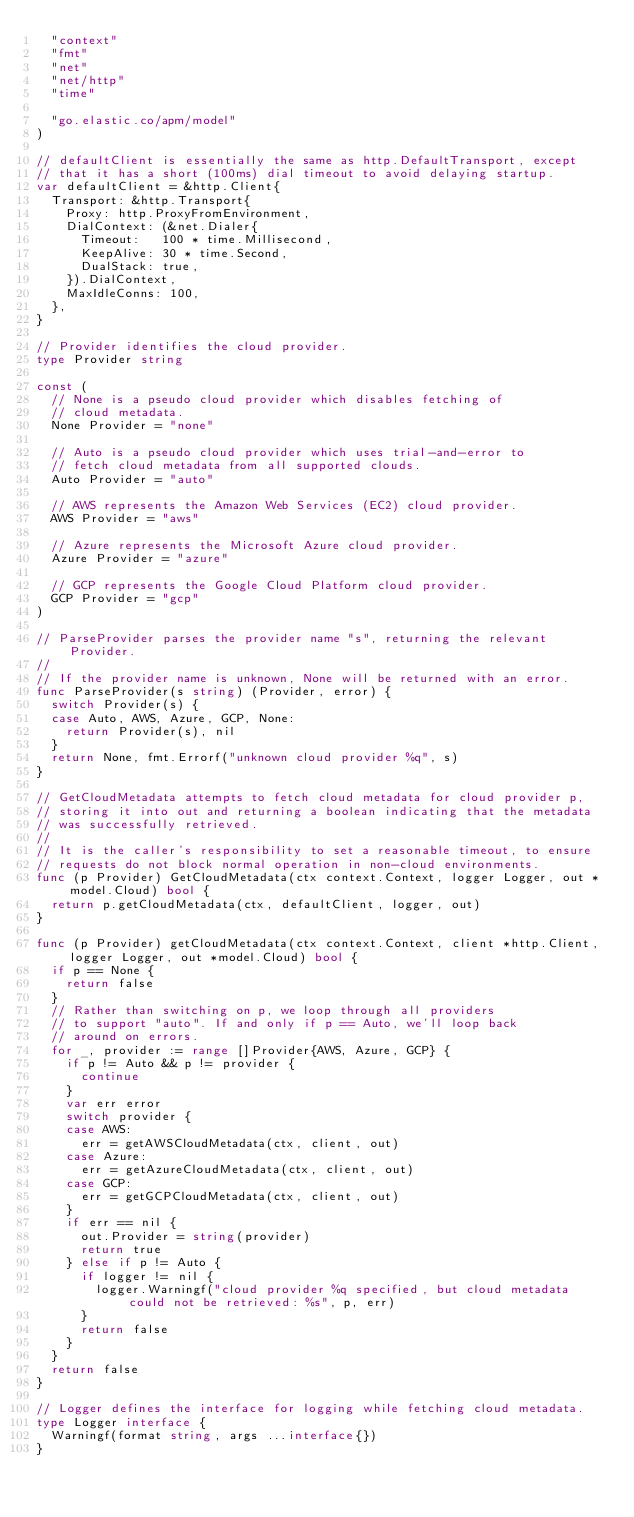<code> <loc_0><loc_0><loc_500><loc_500><_Go_>	"context"
	"fmt"
	"net"
	"net/http"
	"time"

	"go.elastic.co/apm/model"
)

// defaultClient is essentially the same as http.DefaultTransport, except
// that it has a short (100ms) dial timeout to avoid delaying startup.
var defaultClient = &http.Client{
	Transport: &http.Transport{
		Proxy: http.ProxyFromEnvironment,
		DialContext: (&net.Dialer{
			Timeout:   100 * time.Millisecond,
			KeepAlive: 30 * time.Second,
			DualStack: true,
		}).DialContext,
		MaxIdleConns: 100,
	},
}

// Provider identifies the cloud provider.
type Provider string

const (
	// None is a pseudo cloud provider which disables fetching of
	// cloud metadata.
	None Provider = "none"

	// Auto is a pseudo cloud provider which uses trial-and-error to
	// fetch cloud metadata from all supported clouds.
	Auto Provider = "auto"

	// AWS represents the Amazon Web Services (EC2) cloud provider.
	AWS Provider = "aws"

	// Azure represents the Microsoft Azure cloud provider.
	Azure Provider = "azure"

	// GCP represents the Google Cloud Platform cloud provider.
	GCP Provider = "gcp"
)

// ParseProvider parses the provider name "s", returning the relevant Provider.
//
// If the provider name is unknown, None will be returned with an error.
func ParseProvider(s string) (Provider, error) {
	switch Provider(s) {
	case Auto, AWS, Azure, GCP, None:
		return Provider(s), nil
	}
	return None, fmt.Errorf("unknown cloud provider %q", s)
}

// GetCloudMetadata attempts to fetch cloud metadata for cloud provider p,
// storing it into out and returning a boolean indicating that the metadata
// was successfully retrieved.
//
// It is the caller's responsibility to set a reasonable timeout, to ensure
// requests do not block normal operation in non-cloud environments.
func (p Provider) GetCloudMetadata(ctx context.Context, logger Logger, out *model.Cloud) bool {
	return p.getCloudMetadata(ctx, defaultClient, logger, out)
}

func (p Provider) getCloudMetadata(ctx context.Context, client *http.Client, logger Logger, out *model.Cloud) bool {
	if p == None {
		return false
	}
	// Rather than switching on p, we loop through all providers
	// to support "auto". If and only if p == Auto, we'll loop back
	// around on errors.
	for _, provider := range []Provider{AWS, Azure, GCP} {
		if p != Auto && p != provider {
			continue
		}
		var err error
		switch provider {
		case AWS:
			err = getAWSCloudMetadata(ctx, client, out)
		case Azure:
			err = getAzureCloudMetadata(ctx, client, out)
		case GCP:
			err = getGCPCloudMetadata(ctx, client, out)
		}
		if err == nil {
			out.Provider = string(provider)
			return true
		} else if p != Auto {
			if logger != nil {
				logger.Warningf("cloud provider %q specified, but cloud metadata could not be retrieved: %s", p, err)
			}
			return false
		}
	}
	return false
}

// Logger defines the interface for logging while fetching cloud metadata.
type Logger interface {
	Warningf(format string, args ...interface{})
}
</code> 